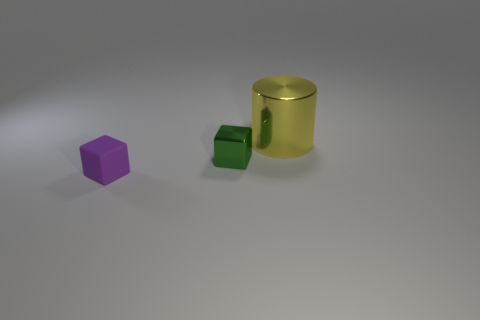Subtract all gray cylinders. Subtract all yellow blocks. How many cylinders are left? 1 Add 2 metallic blocks. How many objects exist? 5 Subtract all cubes. How many objects are left? 1 Subtract all green cylinders. Subtract all green objects. How many objects are left? 2 Add 1 purple rubber objects. How many purple rubber objects are left? 2 Add 2 small blue rubber cylinders. How many small blue rubber cylinders exist? 2 Subtract 0 green cylinders. How many objects are left? 3 